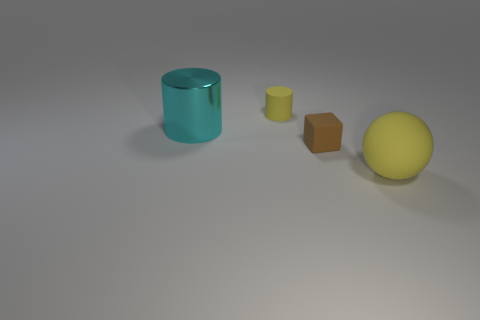What number of shiny objects are either brown objects or small yellow objects?
Ensure brevity in your answer.  0. How many other things are there of the same shape as the cyan object?
Offer a terse response. 1. Is the number of tiny brown cubes greater than the number of large gray rubber objects?
Your answer should be very brief. Yes. What is the size of the yellow thing behind the tiny matte object that is in front of the yellow rubber thing behind the large yellow ball?
Keep it short and to the point. Small. There is a object in front of the small block; what size is it?
Make the answer very short. Large. What number of things are either big cyan shiny cylinders or matte things that are behind the tiny rubber cube?
Your answer should be very brief. 2. How many other objects are there of the same size as the cyan metallic cylinder?
Offer a terse response. 1. There is another thing that is the same shape as the tiny yellow thing; what is it made of?
Offer a terse response. Metal. Is the number of tiny brown rubber objects that are to the left of the big cyan thing greater than the number of brown matte cubes?
Give a very brief answer. No. Is there any other thing that is the same color as the matte sphere?
Your answer should be very brief. Yes. 